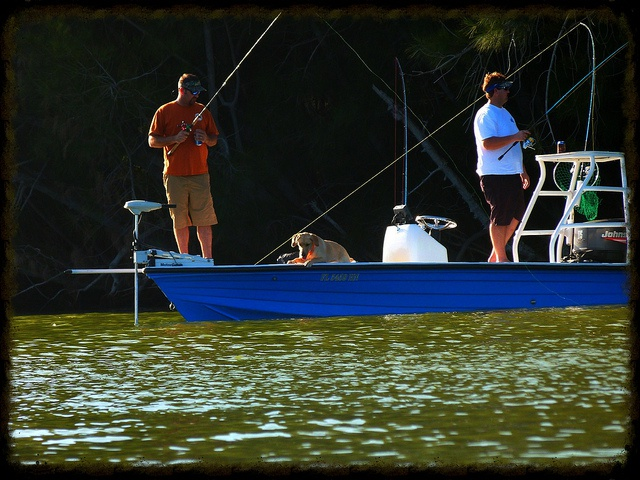Describe the objects in this image and their specific colors. I can see boat in black, darkblue, navy, and darkgreen tones, people in black, maroon, and brown tones, people in black, lightblue, maroon, and white tones, and dog in black, gray, and maroon tones in this image. 